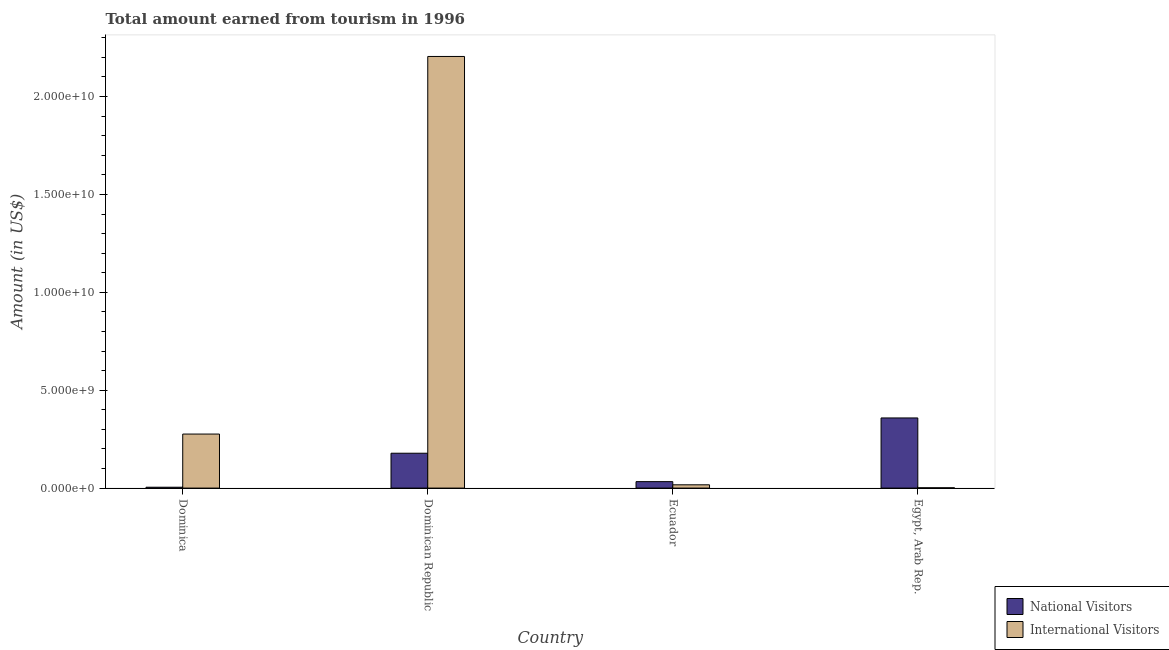How many different coloured bars are there?
Your response must be concise. 2. How many groups of bars are there?
Give a very brief answer. 4. Are the number of bars on each tick of the X-axis equal?
Keep it short and to the point. Yes. What is the label of the 2nd group of bars from the left?
Ensure brevity in your answer.  Dominican Republic. What is the amount earned from international visitors in Ecuador?
Your response must be concise. 1.68e+08. Across all countries, what is the maximum amount earned from international visitors?
Your answer should be very brief. 2.20e+1. Across all countries, what is the minimum amount earned from national visitors?
Provide a succinct answer. 4.40e+07. In which country was the amount earned from international visitors maximum?
Your answer should be compact. Dominican Republic. In which country was the amount earned from national visitors minimum?
Your answer should be very brief. Dominica. What is the total amount earned from national visitors in the graph?
Your answer should be very brief. 5.74e+09. What is the difference between the amount earned from international visitors in Dominica and that in Dominican Republic?
Offer a terse response. -1.93e+1. What is the difference between the amount earned from national visitors in Ecuador and the amount earned from international visitors in Dominican Republic?
Provide a succinct answer. -2.17e+1. What is the average amount earned from national visitors per country?
Give a very brief answer. 1.43e+09. What is the difference between the amount earned from international visitors and amount earned from national visitors in Ecuador?
Offer a very short reply. -1.62e+08. What is the ratio of the amount earned from international visitors in Dominica to that in Ecuador?
Provide a succinct answer. 16.43. Is the difference between the amount earned from national visitors in Ecuador and Egypt, Arab Rep. greater than the difference between the amount earned from international visitors in Ecuador and Egypt, Arab Rep.?
Your answer should be compact. No. What is the difference between the highest and the second highest amount earned from national visitors?
Keep it short and to the point. 1.80e+09. What is the difference between the highest and the lowest amount earned from national visitors?
Your response must be concise. 3.54e+09. Is the sum of the amount earned from national visitors in Dominica and Egypt, Arab Rep. greater than the maximum amount earned from international visitors across all countries?
Keep it short and to the point. No. What does the 2nd bar from the left in Egypt, Arab Rep. represents?
Your answer should be compact. International Visitors. What does the 1st bar from the right in Egypt, Arab Rep. represents?
Offer a terse response. International Visitors. How many bars are there?
Keep it short and to the point. 8. Are all the bars in the graph horizontal?
Offer a terse response. No. How many countries are there in the graph?
Make the answer very short. 4. What is the difference between two consecutive major ticks on the Y-axis?
Your answer should be compact. 5.00e+09. Does the graph contain any zero values?
Provide a short and direct response. No. Does the graph contain grids?
Offer a terse response. No. Where does the legend appear in the graph?
Your answer should be very brief. Bottom right. How are the legend labels stacked?
Make the answer very short. Vertical. What is the title of the graph?
Keep it short and to the point. Total amount earned from tourism in 1996. Does "Methane" appear as one of the legend labels in the graph?
Offer a terse response. No. What is the label or title of the X-axis?
Keep it short and to the point. Country. What is the Amount (in US$) of National Visitors in Dominica?
Provide a succinct answer. 4.40e+07. What is the Amount (in US$) in International Visitors in Dominica?
Give a very brief answer. 2.76e+09. What is the Amount (in US$) in National Visitors in Dominican Republic?
Offer a terse response. 1.78e+09. What is the Amount (in US$) of International Visitors in Dominican Republic?
Keep it short and to the point. 2.20e+1. What is the Amount (in US$) of National Visitors in Ecuador?
Ensure brevity in your answer.  3.30e+08. What is the Amount (in US$) of International Visitors in Ecuador?
Provide a short and direct response. 1.68e+08. What is the Amount (in US$) in National Visitors in Egypt, Arab Rep.?
Your answer should be very brief. 3.58e+09. What is the Amount (in US$) in International Visitors in Egypt, Arab Rep.?
Make the answer very short. 1.55e+07. Across all countries, what is the maximum Amount (in US$) of National Visitors?
Provide a short and direct response. 3.58e+09. Across all countries, what is the maximum Amount (in US$) of International Visitors?
Keep it short and to the point. 2.20e+1. Across all countries, what is the minimum Amount (in US$) of National Visitors?
Ensure brevity in your answer.  4.40e+07. Across all countries, what is the minimum Amount (in US$) of International Visitors?
Ensure brevity in your answer.  1.55e+07. What is the total Amount (in US$) of National Visitors in the graph?
Keep it short and to the point. 5.74e+09. What is the total Amount (in US$) of International Visitors in the graph?
Your answer should be compact. 2.50e+1. What is the difference between the Amount (in US$) in National Visitors in Dominica and that in Dominican Republic?
Your response must be concise. -1.74e+09. What is the difference between the Amount (in US$) in International Visitors in Dominica and that in Dominican Republic?
Offer a terse response. -1.93e+1. What is the difference between the Amount (in US$) in National Visitors in Dominica and that in Ecuador?
Make the answer very short. -2.86e+08. What is the difference between the Amount (in US$) in International Visitors in Dominica and that in Ecuador?
Provide a succinct answer. 2.59e+09. What is the difference between the Amount (in US$) in National Visitors in Dominica and that in Egypt, Arab Rep.?
Provide a short and direct response. -3.54e+09. What is the difference between the Amount (in US$) of International Visitors in Dominica and that in Egypt, Arab Rep.?
Keep it short and to the point. 2.74e+09. What is the difference between the Amount (in US$) of National Visitors in Dominican Republic and that in Ecuador?
Make the answer very short. 1.45e+09. What is the difference between the Amount (in US$) in International Visitors in Dominican Republic and that in Ecuador?
Ensure brevity in your answer.  2.19e+1. What is the difference between the Amount (in US$) in National Visitors in Dominican Republic and that in Egypt, Arab Rep.?
Ensure brevity in your answer.  -1.80e+09. What is the difference between the Amount (in US$) of International Visitors in Dominican Republic and that in Egypt, Arab Rep.?
Make the answer very short. 2.20e+1. What is the difference between the Amount (in US$) in National Visitors in Ecuador and that in Egypt, Arab Rep.?
Provide a short and direct response. -3.25e+09. What is the difference between the Amount (in US$) in International Visitors in Ecuador and that in Egypt, Arab Rep.?
Your answer should be very brief. 1.52e+08. What is the difference between the Amount (in US$) in National Visitors in Dominica and the Amount (in US$) in International Visitors in Dominican Republic?
Your answer should be compact. -2.20e+1. What is the difference between the Amount (in US$) in National Visitors in Dominica and the Amount (in US$) in International Visitors in Ecuador?
Ensure brevity in your answer.  -1.24e+08. What is the difference between the Amount (in US$) in National Visitors in Dominica and the Amount (in US$) in International Visitors in Egypt, Arab Rep.?
Keep it short and to the point. 2.85e+07. What is the difference between the Amount (in US$) in National Visitors in Dominican Republic and the Amount (in US$) in International Visitors in Ecuador?
Offer a very short reply. 1.61e+09. What is the difference between the Amount (in US$) in National Visitors in Dominican Republic and the Amount (in US$) in International Visitors in Egypt, Arab Rep.?
Offer a very short reply. 1.77e+09. What is the difference between the Amount (in US$) of National Visitors in Ecuador and the Amount (in US$) of International Visitors in Egypt, Arab Rep.?
Make the answer very short. 3.14e+08. What is the average Amount (in US$) of National Visitors per country?
Your answer should be very brief. 1.43e+09. What is the average Amount (in US$) of International Visitors per country?
Your answer should be compact. 6.25e+09. What is the difference between the Amount (in US$) in National Visitors and Amount (in US$) in International Visitors in Dominica?
Offer a very short reply. -2.72e+09. What is the difference between the Amount (in US$) in National Visitors and Amount (in US$) in International Visitors in Dominican Republic?
Offer a very short reply. -2.03e+1. What is the difference between the Amount (in US$) of National Visitors and Amount (in US$) of International Visitors in Ecuador?
Keep it short and to the point. 1.62e+08. What is the difference between the Amount (in US$) of National Visitors and Amount (in US$) of International Visitors in Egypt, Arab Rep.?
Offer a terse response. 3.57e+09. What is the ratio of the Amount (in US$) in National Visitors in Dominica to that in Dominican Republic?
Your answer should be very brief. 0.02. What is the ratio of the Amount (in US$) in International Visitors in Dominica to that in Dominican Republic?
Ensure brevity in your answer.  0.13. What is the ratio of the Amount (in US$) in National Visitors in Dominica to that in Ecuador?
Offer a terse response. 0.13. What is the ratio of the Amount (in US$) in International Visitors in Dominica to that in Ecuador?
Keep it short and to the point. 16.43. What is the ratio of the Amount (in US$) in National Visitors in Dominica to that in Egypt, Arab Rep.?
Your response must be concise. 0.01. What is the ratio of the Amount (in US$) in International Visitors in Dominica to that in Egypt, Arab Rep.?
Provide a succinct answer. 178.06. What is the ratio of the Amount (in US$) of National Visitors in Dominican Republic to that in Ecuador?
Give a very brief answer. 5.4. What is the ratio of the Amount (in US$) in International Visitors in Dominican Republic to that in Ecuador?
Provide a succinct answer. 131.24. What is the ratio of the Amount (in US$) in National Visitors in Dominican Republic to that in Egypt, Arab Rep.?
Your answer should be compact. 0.5. What is the ratio of the Amount (in US$) of International Visitors in Dominican Republic to that in Egypt, Arab Rep.?
Ensure brevity in your answer.  1422.52. What is the ratio of the Amount (in US$) of National Visitors in Ecuador to that in Egypt, Arab Rep.?
Give a very brief answer. 0.09. What is the ratio of the Amount (in US$) of International Visitors in Ecuador to that in Egypt, Arab Rep.?
Provide a short and direct response. 10.84. What is the difference between the highest and the second highest Amount (in US$) of National Visitors?
Offer a terse response. 1.80e+09. What is the difference between the highest and the second highest Amount (in US$) in International Visitors?
Give a very brief answer. 1.93e+1. What is the difference between the highest and the lowest Amount (in US$) in National Visitors?
Offer a very short reply. 3.54e+09. What is the difference between the highest and the lowest Amount (in US$) of International Visitors?
Your answer should be very brief. 2.20e+1. 